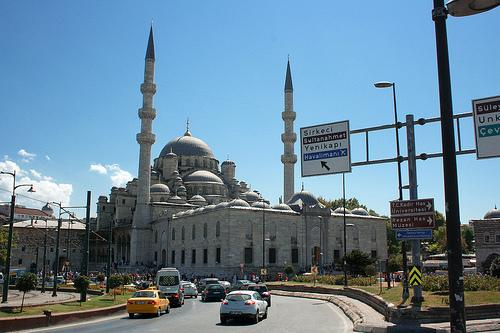What is the main color of the taxi in the image? The main color of the taxi is yellow. Provide a summary of the visual information about the sky in the image. The sky is clear and blue with clouds peeking behind the buildings. How many towers can be spotted on the building in the image? There are two towers on the building. Describe the type of signs seen in the image. They are traffic signs; including neon-yellow and black signs, brown signs, blue sign, and a non-English illegible sign. Some are located on poles, and one is on a small wall. Explain the traffic situation in this image. There are various vehicles on the road, including a stalled white car, a yellow taxi cab, and cars stopped at a traffic light while others are driving. Enumerate the colors of the signs found in the image. The colors of the signs are neon yellow, black, brown, and blue. What type of vehicle is mentioned as having break lights on in the image? A small passenger bus has break lights on. Explain what the street light in the image is positioned near. The street light is positioned near the grass area. Write a brief description of the scene depicted in the image. The image shows a busy street with various cars driving and stopped at a traffic light, a yellow taxi cab, a dome-topped building, and traffic signs on poles directing the flow along the road. Identify the unique feature of the building in this image. The unique feature of the building is its domed top. Is the sign on the grass green and white? The sign mentioned in the image is described as neon yellow and black, not green and white. Are the clouds in the sky covering the entire view of the buildings? No, it's not mentioned in the image. Are the two towers on the building connected by a bridge? There is no mention of a bridge connecting the two towers on the building in the image. Can you see a red umbrella next to the brick retaining wall beside the grass area? There is no mention of a red umbrella in the image, so this instruction introduces a non-existent object. Is the small passenger bus painted blue and red? The color of the small passenger bus is not mentioned, so this instruction provides misleading information about its colors. Does the yellow taxi cab have blue stripes? There is no mention of blue stripes on the yellow taxi cab in the image. 